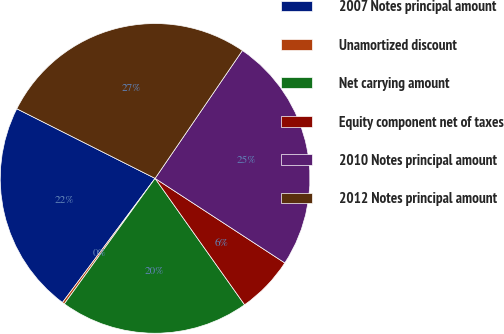<chart> <loc_0><loc_0><loc_500><loc_500><pie_chart><fcel>2007 Notes principal amount<fcel>Unamortized discount<fcel>Net carrying amount<fcel>Equity component net of taxes<fcel>2010 Notes principal amount<fcel>2012 Notes principal amount<nl><fcel>22.22%<fcel>0.24%<fcel>19.77%<fcel>6.0%<fcel>24.66%<fcel>27.11%<nl></chart> 